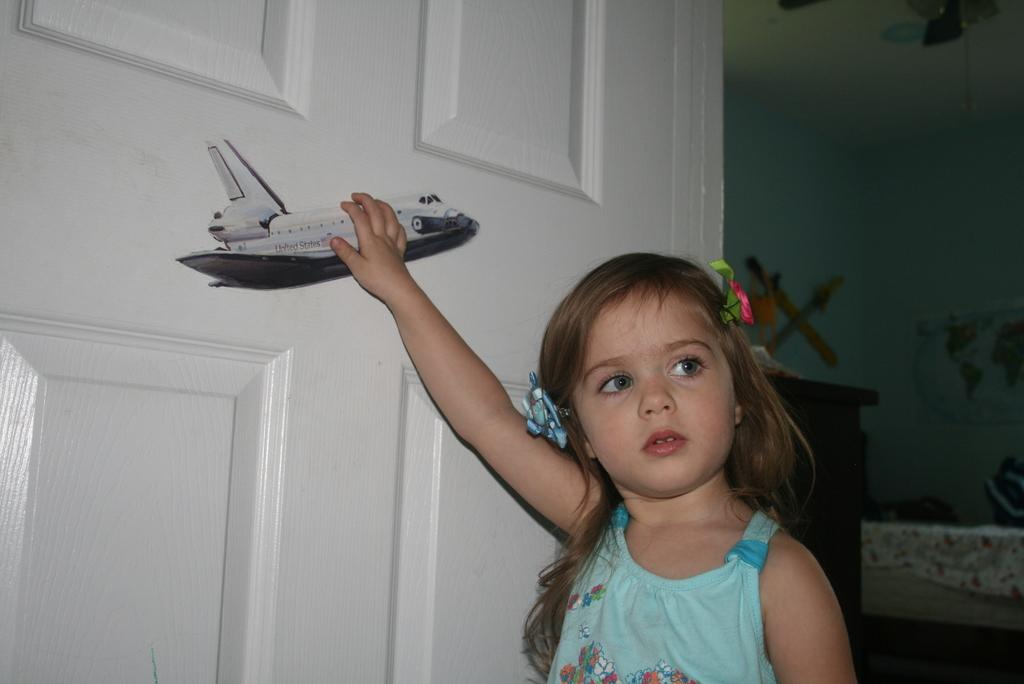What is the main subject of the image? The main subject of the image is a kid. What is the kid wearing? The kid is wearing clothes. What object is the kid holding? The kid is holding an airplane toy. What can be seen in the middle of the image? There is a door in the middle of the image. What is on the right side of the image? There is a wall on the right side of the image. Where is the kettle located in the image? There is no kettle present in the image. Is the kid wearing a boot in the image? The provided facts do not mention any boots, so we cannot determine if the kid is wearing a boot. --- Facts: 1. There is a car in the image. 2. The car is red. 3. The car has four wheels. 4. There is a road in the image. 5. The road is paved. Absurd Topics: bird, umbrella, ocean Conversation: What is the main subject of the image? The main subject of the image is a car. What color is the car? The car is red. How many wheels does the car have? The car has four wheels. What can be seen in the background of the image? There is a road in the image. What is the condition of the road? The road is paved. Reasoning: Let's think step by step in order to produce the conversation. We start by identifying the main subject of the image, which is the car. Then, we describe the car's color and the number of wheels it has. Next, we mention the road, which is visible in the background, and describe its condition. Each question is designed to elicit a specific detail about the image that is known from the provided facts. Absurd Question/Answer: Can you see any birds flying over the ocean in the image? There is no ocean or birds present in the image. Is the car carrying an umbrella in the image? The provided facts do not mention an umbrella, so we cannot determine if the car is carrying one. 